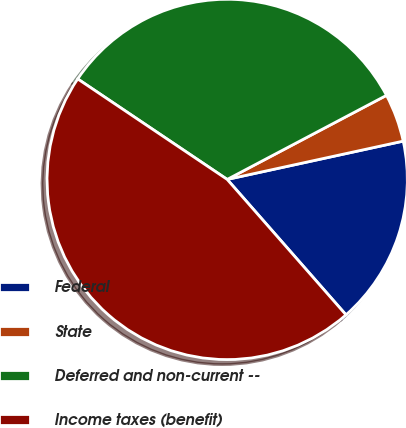Convert chart to OTSL. <chart><loc_0><loc_0><loc_500><loc_500><pie_chart><fcel>Federal<fcel>State<fcel>Deferred and non-current --<fcel>Income taxes (benefit)<nl><fcel>16.95%<fcel>4.32%<fcel>32.85%<fcel>45.88%<nl></chart> 